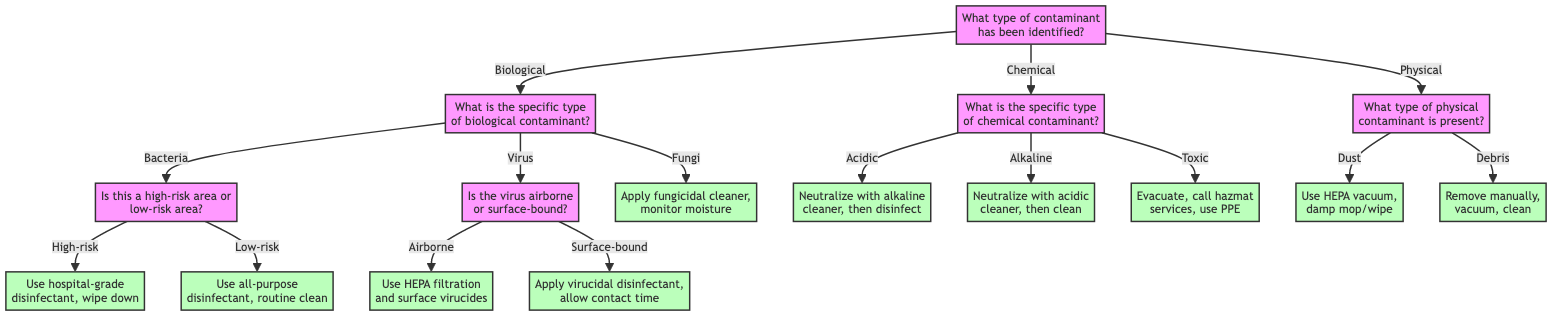What is the first question in the decision tree? The first question in the decision tree is located at the root node, which asks about the type of contaminant that has been identified.
Answer: What type of contaminant has been identified? How many types of biological contaminants are specified in the diagram? The diagram specifies three types of biological contaminants: bacteria, virus, and fungi. By counting each listed type, the total comes to three.
Answer: 3 What action is taken if the identified contaminant is bacteria in a high-risk area? The path from the root indicates that if bacteria are identified in a high-risk area, the action is to use a hospital-grade disinfectant and ensure a thorough wipe down with clean cloths.
Answer: Use a hospital-grade disinfectant and ensure to follow up with a thorough wipe down with clean cloths Which contaminant requires evacuation and hazardous material removal services? The node for toxic chemical contaminants specifies that if a toxic contaminant is identified, the area must be evacuated, and professional hazardous material removal services should be called.
Answer: Toxic What is the action taken for airborne viruses? Following the decision for airborne viruses, the next step indicates the action is to employ HEPA air filtration and surface disinfection using appropriate virucides.
Answer: Employ HEPA air filtration and surface disinfection using appropriate virucides What type of physical contaminant leads to using a HEPA vacuum? The decision tree shows that if dust is identified as the physical contaminant, it leads to the action of using a vacuum with a HEPA filter for removal.
Answer: Dust If a contaminant is identified as alkaline, what is the immediate required action? The response path for alkaline contaminants indicates that they must first be neutralized with a suitable acidic cleaner, followed by applying a standard cleaning regimen.
Answer: Neutralize with a suitable acidic cleaner and then apply a standard cleaning regimen What is the total number of decisions in the tree regarding chemical contaminants? The tree illustrates three specific decisions related to chemical contaminants: acidic, alkaline, and toxic. Therefore, the total number of decisions regarding chemical contaminants is three.
Answer: 3 